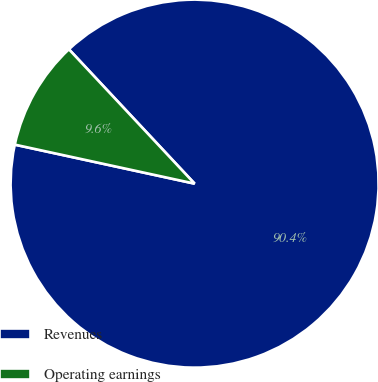Convert chart to OTSL. <chart><loc_0><loc_0><loc_500><loc_500><pie_chart><fcel>Revenues<fcel>Operating earnings<nl><fcel>90.37%<fcel>9.63%<nl></chart> 